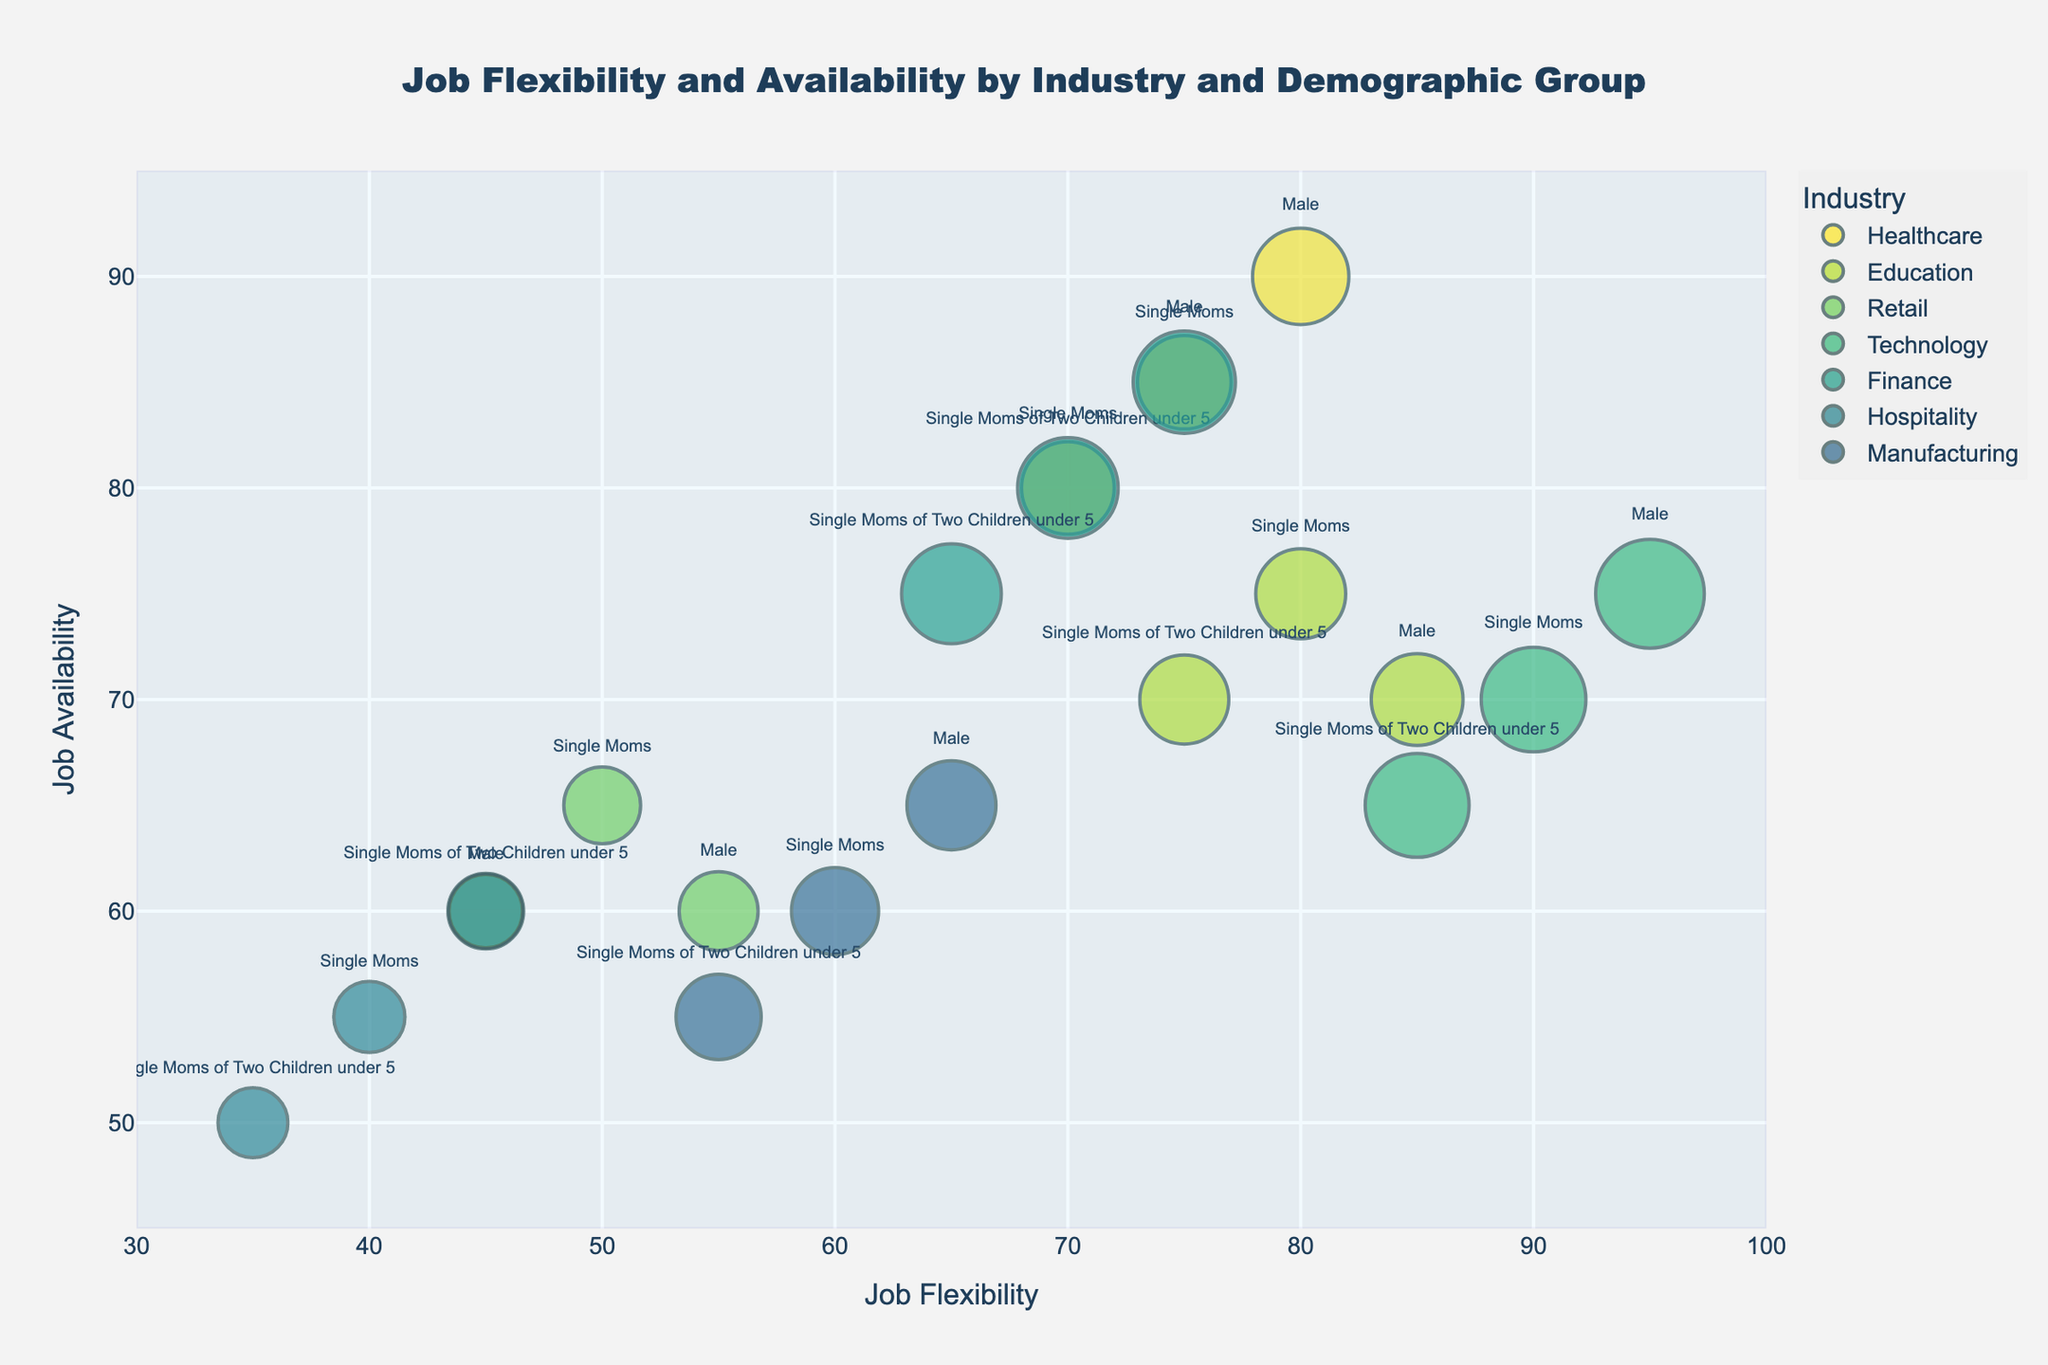what is the title of the figure? The title of the figure is shown at the top center of the chart, in bold and large font. The text is "Job Flexibility and Availability by Industry and Demographic Group".
Answer: Job Flexibility and Availability by Industry and Demographic Group How many unique industries are represented in the figure? Each bubble is colored and labeled individually for different industries. Counting the unique labels, we find Healthcare, Education, Retail, Technology, Finance, Hospitality, and Manufacturing.
Answer: 7 Which industry has the highest job flexibility for single moms with two children under 5? From the scatter plot, find the industry with the highest x-value for the "Single Moms of Two Children under 5" demographic group. The highest value is for Technology with a flexibility score of 85.
Answer: Technology Which industry provides the highest median salary for single moms of two children under 5? Median salary is represented by the size of the bubbles; the largest bubble for "Single Moms of Two Children under 5" represents Technology, showing the highest median salary.
Answer: Technology What is the job availability range depicted on the y-axis? The y-axis title is "Job Availability", and the range is set between 45 to 95.
Answer: 45 to 95 Between single moms in Healthcare and Finance, which group has higher job flexibility and by how much? Comparing the x-values of Healthcare (75) and Finance (70) bubbles for single moms, Healthcare has 5 points higher in job flexibility.
Answer: Healthcare, 5 For which demographic group is the hospitality industry least beneficial in terms of job flexibility? From the scatter plot, compare job flexibility values of different demographic groups within the Hospitality industry. Single Moms of Two Children under 5 have the lowest flexibility score of 35.
Answer: Single Moms of Two Children under 5 Which industry shows the greatest job availability for male workers? Looking at the y-values for male workers, the Healthcare industry has the highest job availability value of 90.
Answer: Healthcare What is the median salary difference between single mom workers and male workers in the retail industry? Single mom workers in Retail have a median salary of $35,000, while male workers have $37,000. The difference is $37,000 - $35,000 = $2,000.
Answer: $2,000 Which industry offers better job flexibility and availability for single moms compared to single moms of two children under 5? Compare the x (flexibility) and y (availability) values for single moms and single moms of two children in Healthcare, Education, Retail, Technology, Finance, Hospitality, and Manufacturing. Both values are higher for single moms in Healthcare, 75 > 70 and 85 > 80 respectively.
Answer: Healthcare 